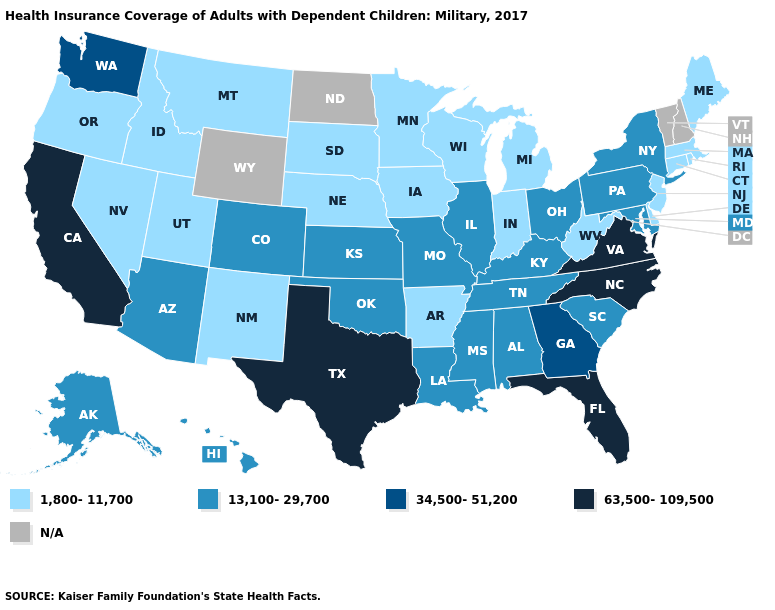Does the map have missing data?
Answer briefly. Yes. What is the value of Maine?
Keep it brief. 1,800-11,700. Name the states that have a value in the range 13,100-29,700?
Give a very brief answer. Alabama, Alaska, Arizona, Colorado, Hawaii, Illinois, Kansas, Kentucky, Louisiana, Maryland, Mississippi, Missouri, New York, Ohio, Oklahoma, Pennsylvania, South Carolina, Tennessee. Does New Jersey have the lowest value in the USA?
Write a very short answer. Yes. Does the first symbol in the legend represent the smallest category?
Answer briefly. Yes. Among the states that border Virginia , which have the highest value?
Short answer required. North Carolina. What is the highest value in the West ?
Quick response, please. 63,500-109,500. Does Arkansas have the lowest value in the South?
Short answer required. Yes. What is the value of Delaware?
Keep it brief. 1,800-11,700. Name the states that have a value in the range 13,100-29,700?
Concise answer only. Alabama, Alaska, Arizona, Colorado, Hawaii, Illinois, Kansas, Kentucky, Louisiana, Maryland, Mississippi, Missouri, New York, Ohio, Oklahoma, Pennsylvania, South Carolina, Tennessee. What is the value of New Hampshire?
Answer briefly. N/A. Name the states that have a value in the range 63,500-109,500?
Be succinct. California, Florida, North Carolina, Texas, Virginia. What is the value of Connecticut?
Write a very short answer. 1,800-11,700. What is the value of Kansas?
Be succinct. 13,100-29,700. 